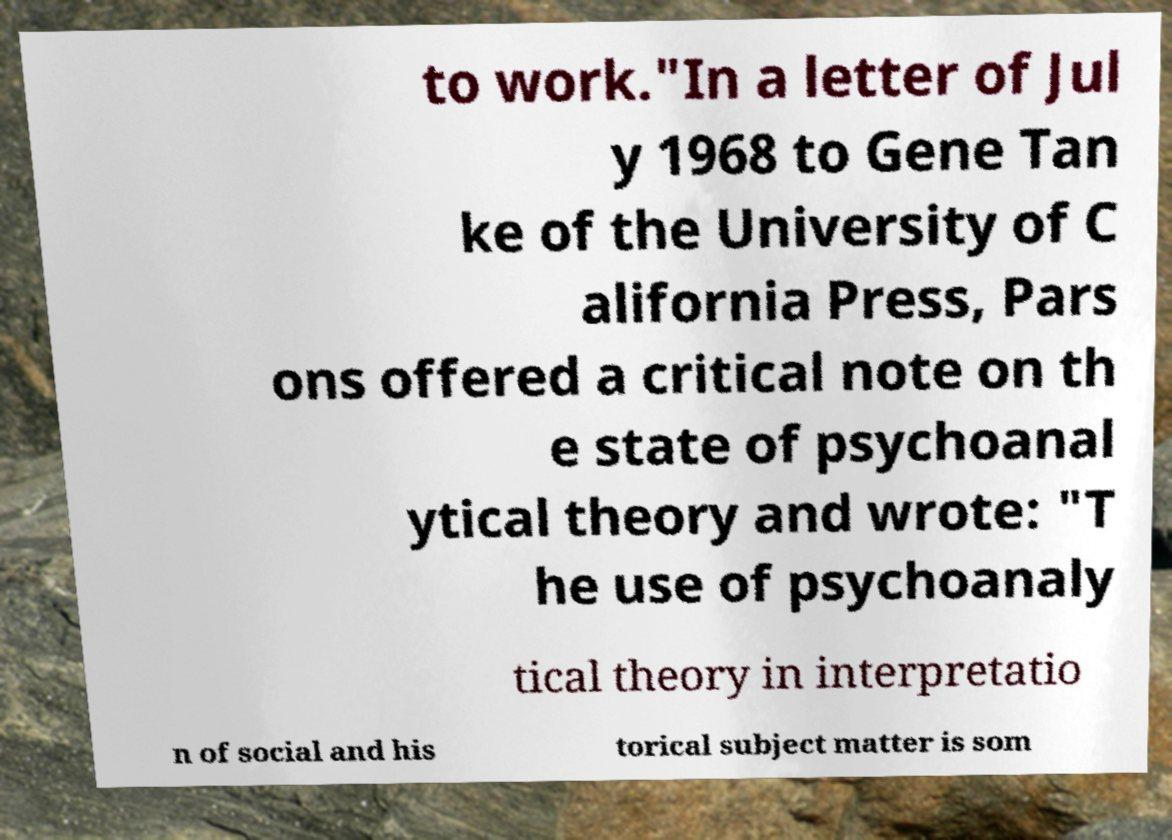For documentation purposes, I need the text within this image transcribed. Could you provide that? to work."In a letter of Jul y 1968 to Gene Tan ke of the University of C alifornia Press, Pars ons offered a critical note on th e state of psychoanal ytical theory and wrote: "T he use of psychoanaly tical theory in interpretatio n of social and his torical subject matter is som 